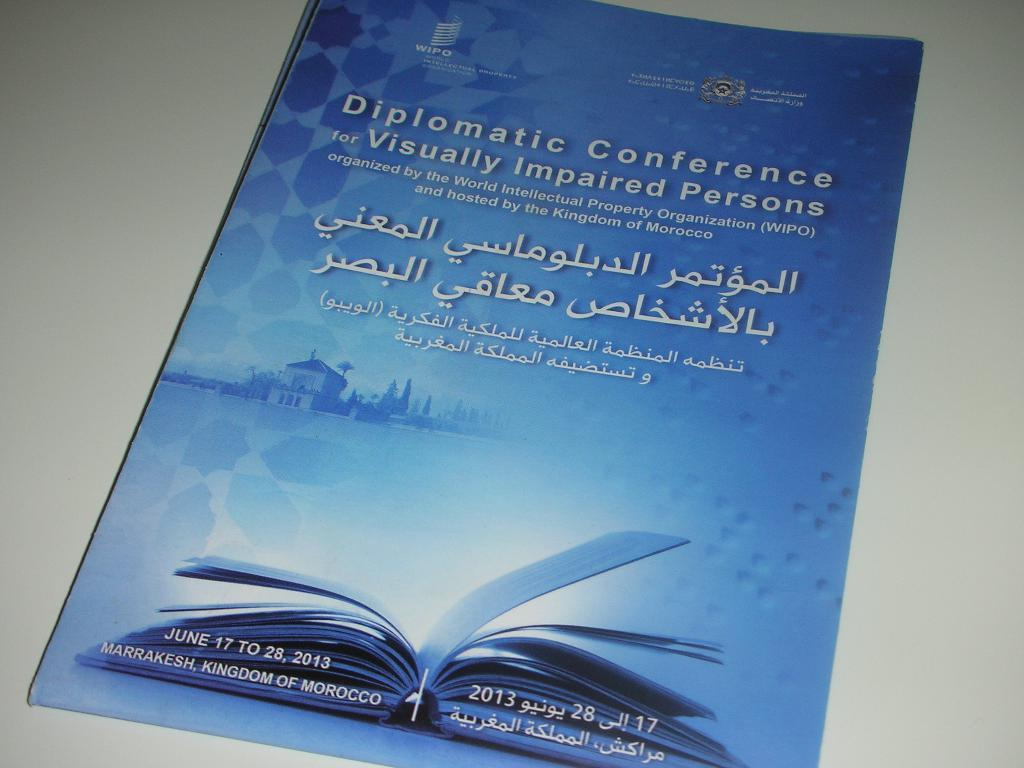Provide a one-sentence caption for the provided image. a flyer for a Diplomatic Conference for Visually Impaired Persons. 